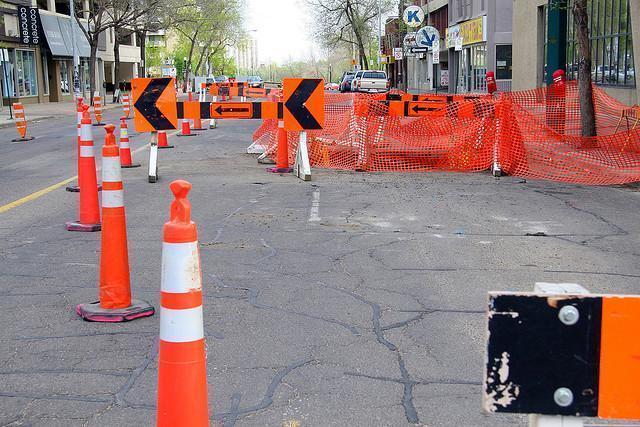Where are repairs taking place here?
Pick the right solution, then justify: 'Answer: answer
Rationale: rationale.'
Options: Sidewalk only, street, automobiles, parking garage. Answer: street.
Rationale: There are repairs taking place on the street top. 